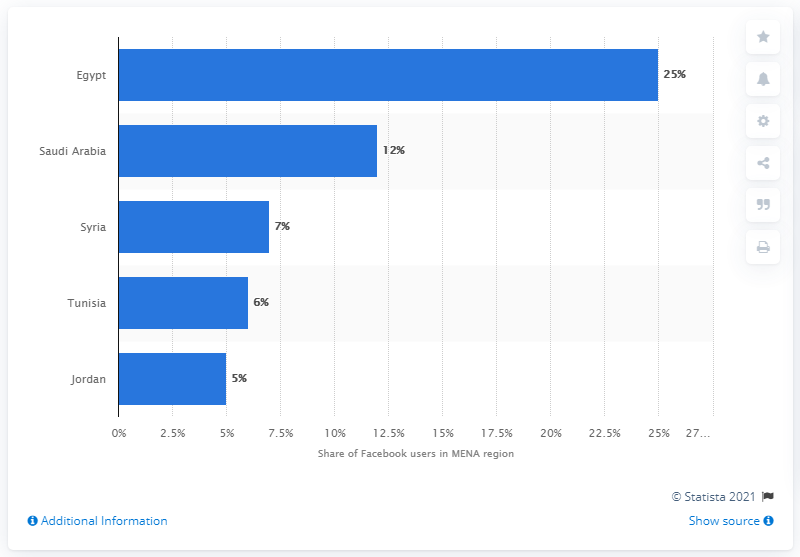Highlight a few significant elements in this photo. In June 2012, approximately 25% of Facebook users were located in Egypt. 